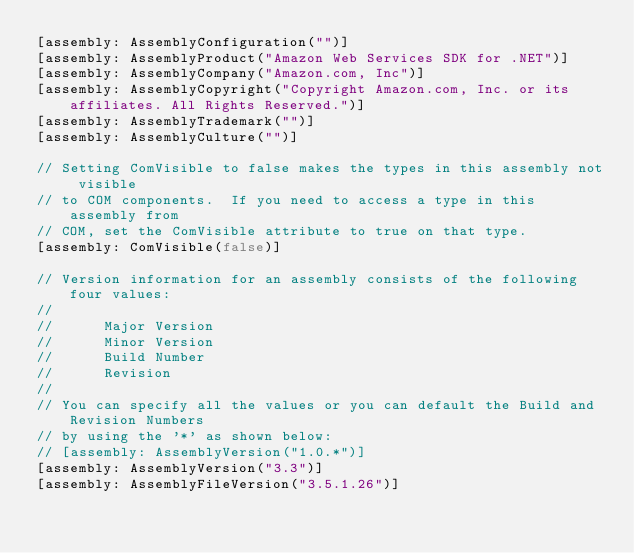<code> <loc_0><loc_0><loc_500><loc_500><_C#_>[assembly: AssemblyConfiguration("")]
[assembly: AssemblyProduct("Amazon Web Services SDK for .NET")]
[assembly: AssemblyCompany("Amazon.com, Inc")]
[assembly: AssemblyCopyright("Copyright Amazon.com, Inc. or its affiliates. All Rights Reserved.")]
[assembly: AssemblyTrademark("")]
[assembly: AssemblyCulture("")]

// Setting ComVisible to false makes the types in this assembly not visible 
// to COM components.  If you need to access a type in this assembly from 
// COM, set the ComVisible attribute to true on that type.
[assembly: ComVisible(false)]

// Version information for an assembly consists of the following four values:
//
//      Major Version
//      Minor Version 
//      Build Number
//      Revision
//
// You can specify all the values or you can default the Build and Revision Numbers 
// by using the '*' as shown below:
// [assembly: AssemblyVersion("1.0.*")]
[assembly: AssemblyVersion("3.3")]
[assembly: AssemblyFileVersion("3.5.1.26")]</code> 